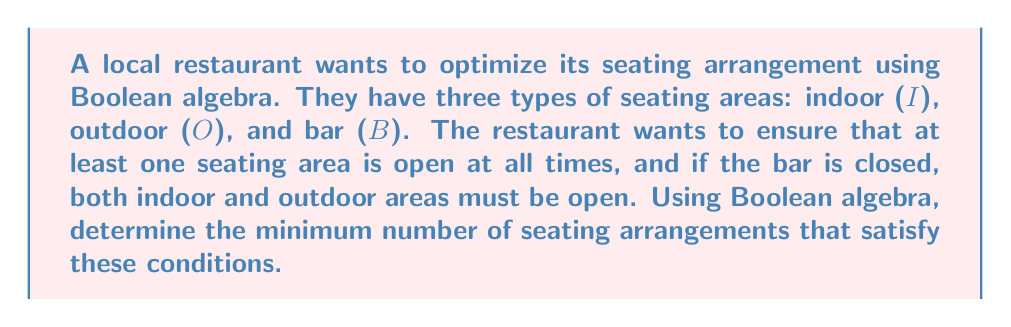Show me your answer to this math problem. Let's approach this step-by-step using Boolean algebra:

1) First, we need to express the given conditions in Boolean algebra:
   - At least one seating area is open: $I + O + B = 1$
   - If the bar is closed, both indoor and outdoor areas must be open: $\bar{B} \rightarrow (I \cdot O)$

2) We can express the second condition as: $B + (I \cdot O) = 1$

3) Now, we have two equations:
   $I + O + B = 1$
   $B + (I \cdot O) = 1$

4) Let's create a truth table for these conditions:

   $$
   \begin{array}{|c|c|c|c|c|}
   \hline
   I & O & B & I + O + B & B + (I \cdot O) \\
   \hline
   0 & 0 & 0 & 0 & 0 \\
   0 & 0 & 1 & 1 & 1 \\
   0 & 1 & 0 & 1 & 0 \\
   0 & 1 & 1 & 1 & 1 \\
   1 & 0 & 0 & 1 & 0 \\
   1 & 0 & 1 & 1 & 1 \\
   1 & 1 & 0 & 1 & 1 \\
   1 & 1 & 1 & 1 & 1 \\
   \hline
   \end{array}
   $$

5) The valid arrangements are those where both conditions are met (both columns are 1):
   - $(I,O,B) = (0,0,1)$
   - $(I,O,B) = (0,1,1)$
   - $(I,O,B) = (1,0,1)$
   - $(I,O,B) = (1,1,0)$
   - $(I,O,B) = (1,1,1)$

6) Therefore, there are 5 valid seating arrangements that satisfy the given conditions.
Answer: 5 